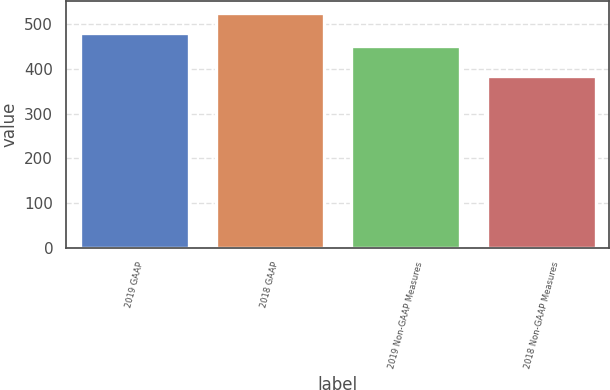Convert chart to OTSL. <chart><loc_0><loc_0><loc_500><loc_500><bar_chart><fcel>2019 GAAP<fcel>2018 GAAP<fcel>2019 Non-GAAP Measures<fcel>2018 Non-GAAP Measures<nl><fcel>480.1<fcel>524.3<fcel>451.1<fcel>383.3<nl></chart> 